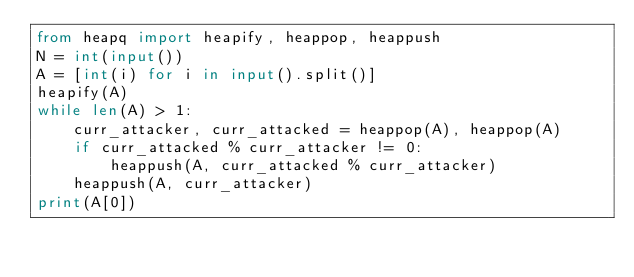<code> <loc_0><loc_0><loc_500><loc_500><_Python_>from heapq import heapify, heappop, heappush
N = int(input())
A = [int(i) for i in input().split()]
heapify(A)
while len(A) > 1:
    curr_attacker, curr_attacked = heappop(A), heappop(A)
    if curr_attacked % curr_attacker != 0:
        heappush(A, curr_attacked % curr_attacker)
    heappush(A, curr_attacker)
print(A[0])</code> 